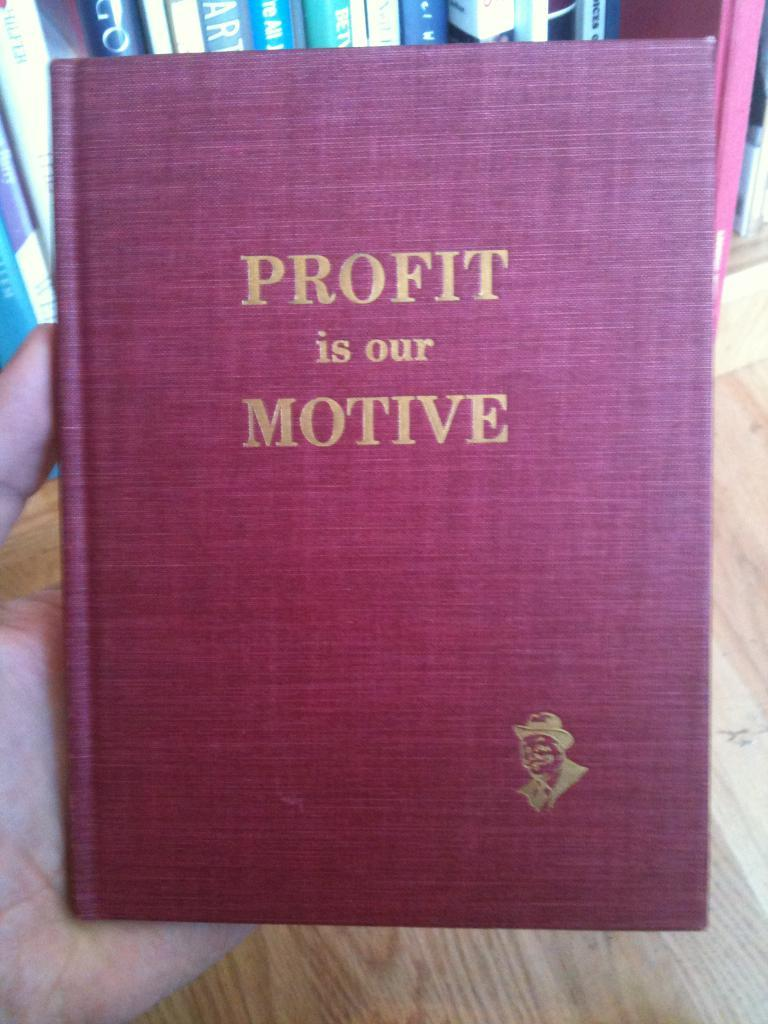<image>
Give a short and clear explanation of the subsequent image. A red book with gold writing entitled Profit is our Motive. 